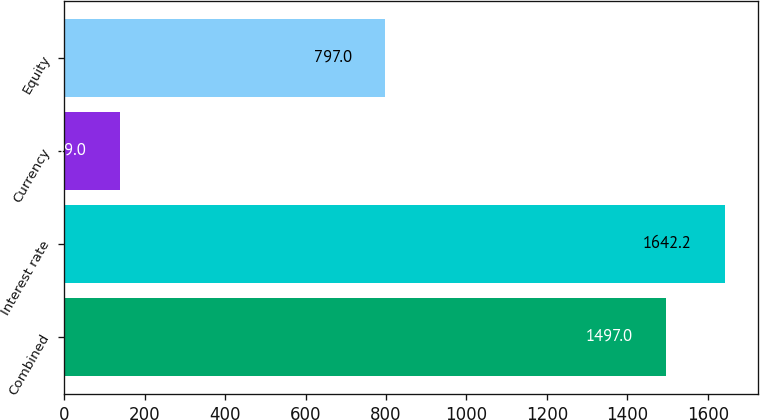Convert chart. <chart><loc_0><loc_0><loc_500><loc_500><bar_chart><fcel>Combined<fcel>Interest rate<fcel>Currency<fcel>Equity<nl><fcel>1497<fcel>1642.2<fcel>139<fcel>797<nl></chart> 